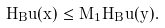Convert formula to latex. <formula><loc_0><loc_0><loc_500><loc_500>H _ { B } u ( x ) \leq M _ { 1 } H _ { B } u ( y ) .</formula> 